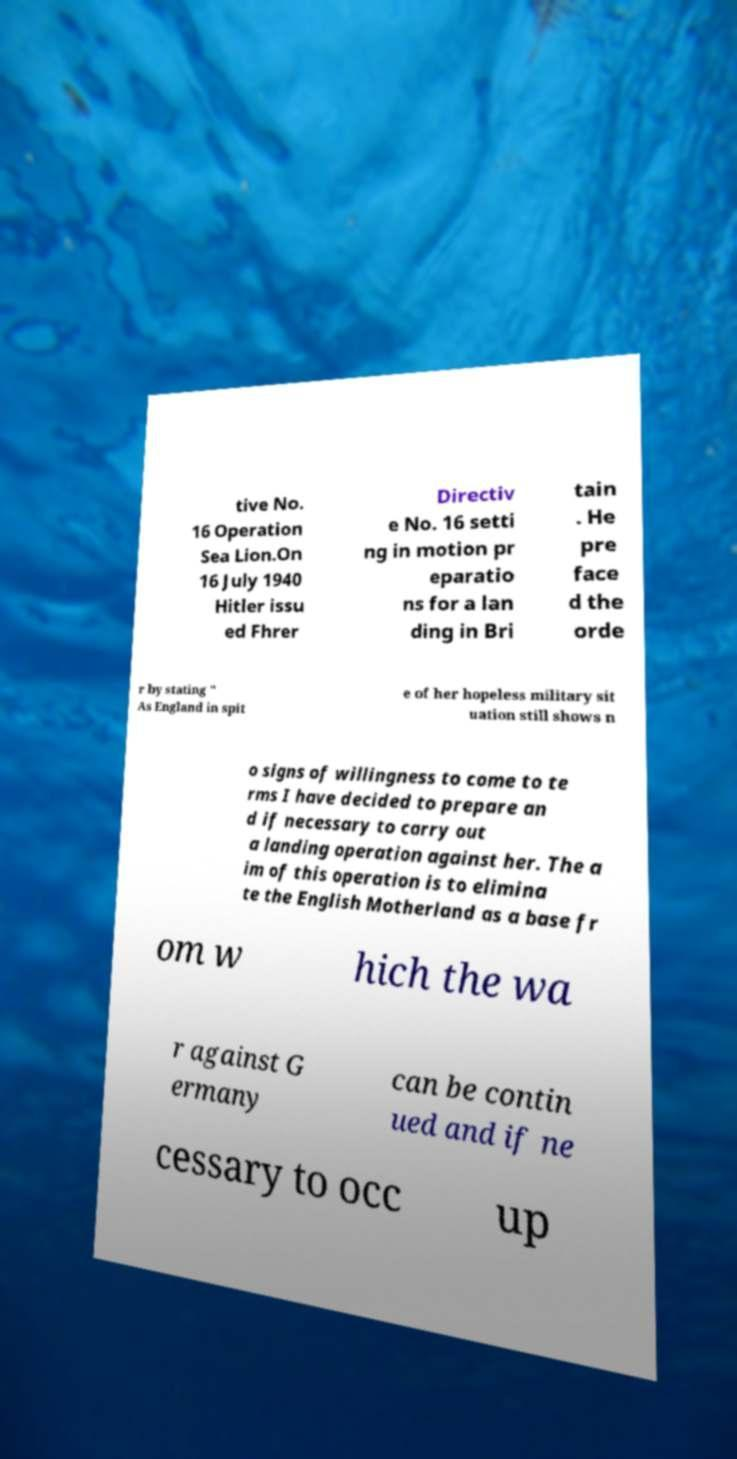Can you accurately transcribe the text from the provided image for me? tive No. 16 Operation Sea Lion.On 16 July 1940 Hitler issu ed Fhrer Directiv e No. 16 setti ng in motion pr eparatio ns for a lan ding in Bri tain . He pre face d the orde r by stating " As England in spit e of her hopeless military sit uation still shows n o signs of willingness to come to te rms I have decided to prepare an d if necessary to carry out a landing operation against her. The a im of this operation is to elimina te the English Motherland as a base fr om w hich the wa r against G ermany can be contin ued and if ne cessary to occ up 